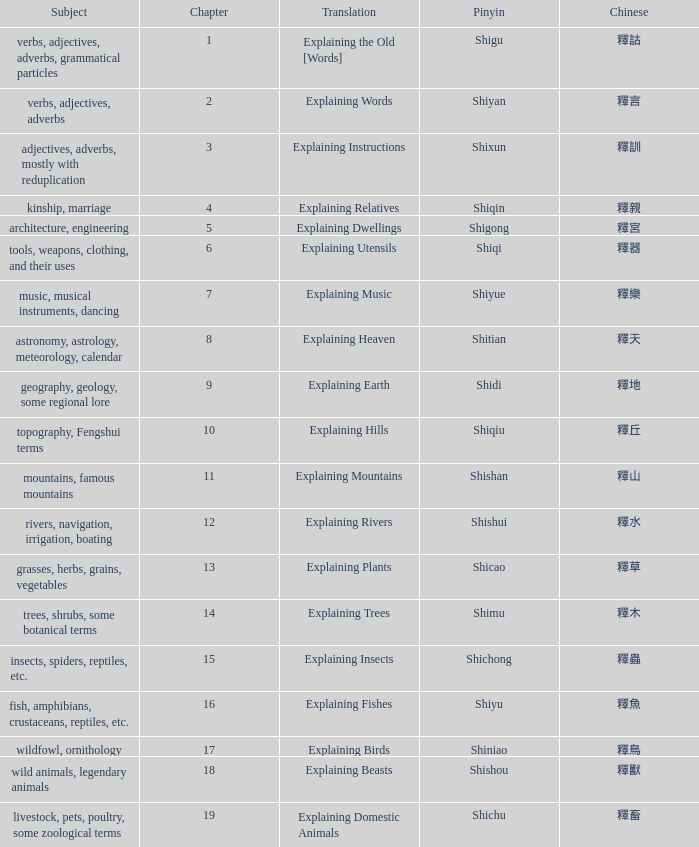Name the chinese with subject of adjectives, adverbs, mostly with reduplication 釋訓. 